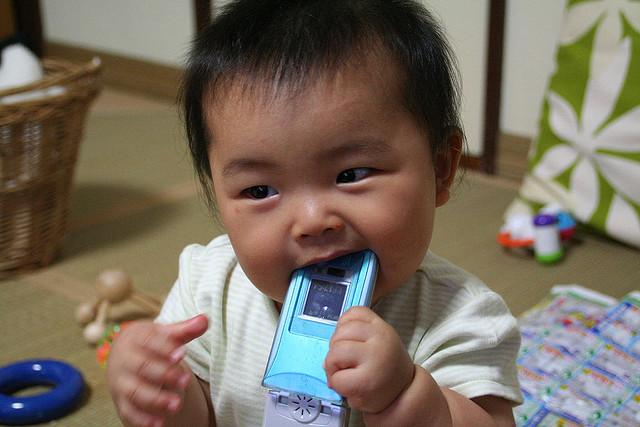Is this person a grown up?
Quick response, please. No. Are there toys on the floor?
Write a very short answer. Yes. What is dangerous about this action?
Write a very short answer. Germs. 